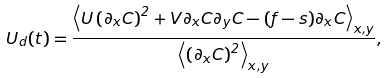Convert formula to latex. <formula><loc_0><loc_0><loc_500><loc_500>U _ { d } ( t ) = \frac { \left \langle U \left ( \partial _ { x } C \right ) ^ { 2 } + V \partial _ { x } C \partial _ { y } C - ( f - s ) \partial _ { x } C \right \rangle _ { x , y } } { \left \langle \left ( \partial _ { x } C \right ) ^ { 2 } \right \rangle _ { x , y } } ,</formula> 